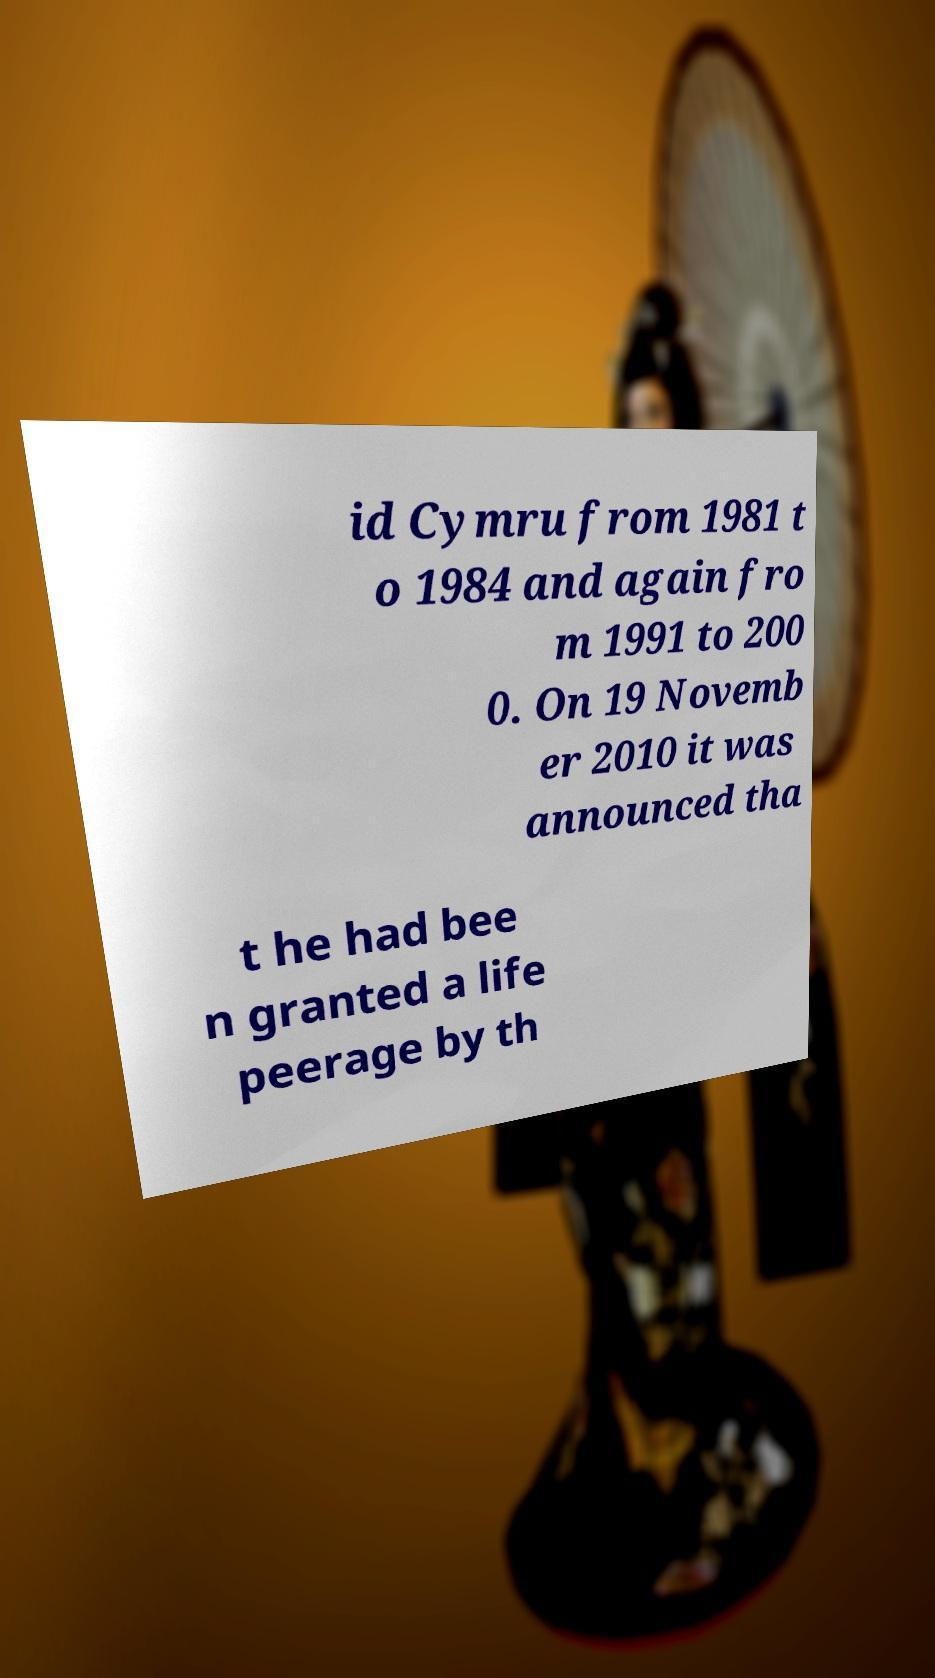Please identify and transcribe the text found in this image. id Cymru from 1981 t o 1984 and again fro m 1991 to 200 0. On 19 Novemb er 2010 it was announced tha t he had bee n granted a life peerage by th 